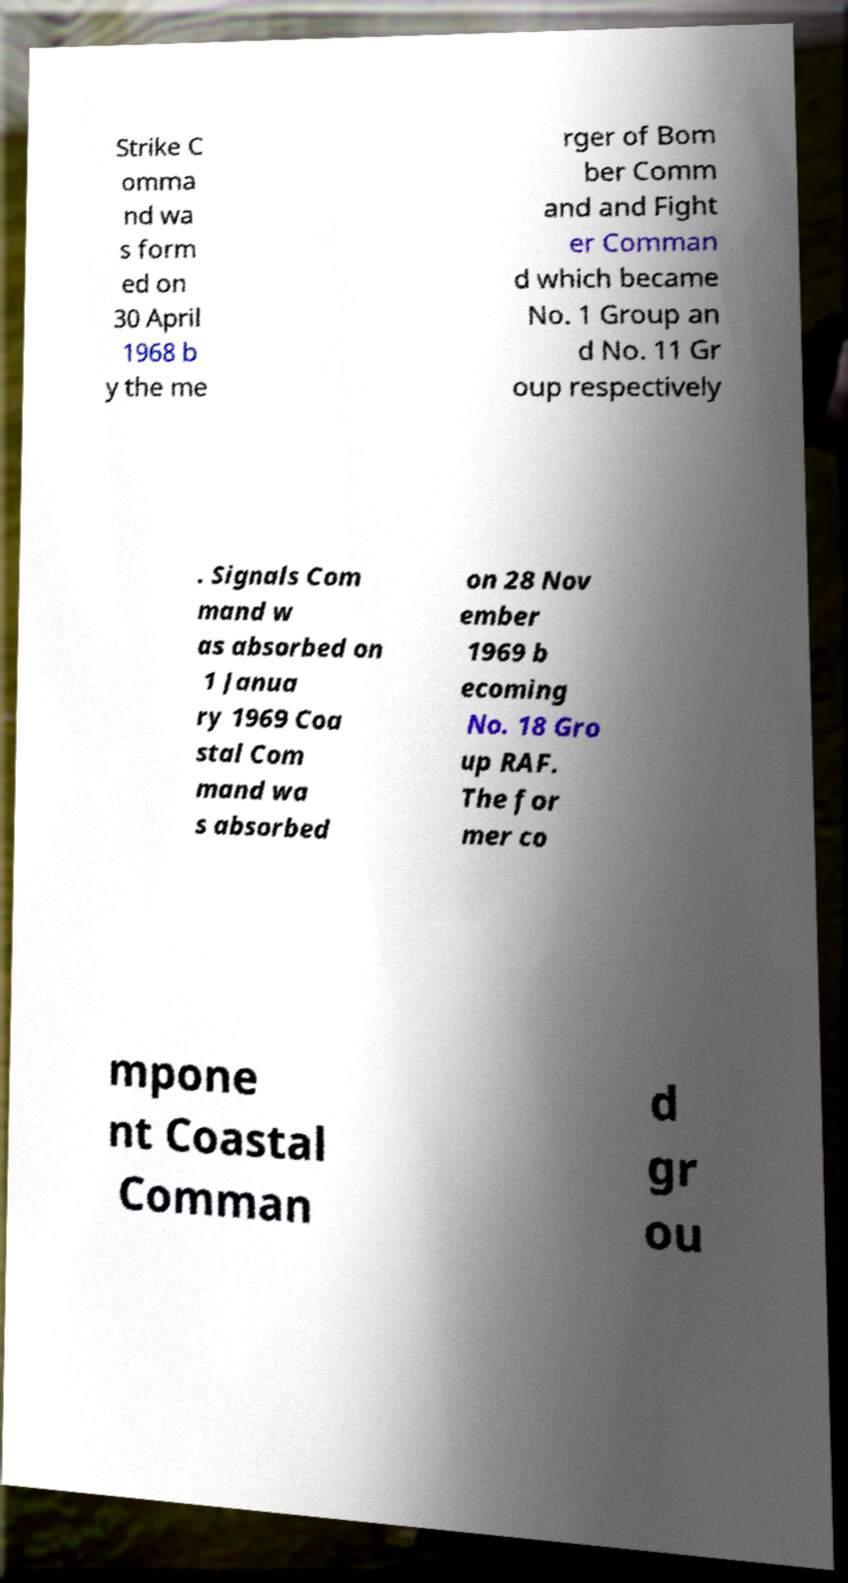There's text embedded in this image that I need extracted. Can you transcribe it verbatim? Strike C omma nd wa s form ed on 30 April 1968 b y the me rger of Bom ber Comm and and Fight er Comman d which became No. 1 Group an d No. 11 Gr oup respectively . Signals Com mand w as absorbed on 1 Janua ry 1969 Coa stal Com mand wa s absorbed on 28 Nov ember 1969 b ecoming No. 18 Gro up RAF. The for mer co mpone nt Coastal Comman d gr ou 